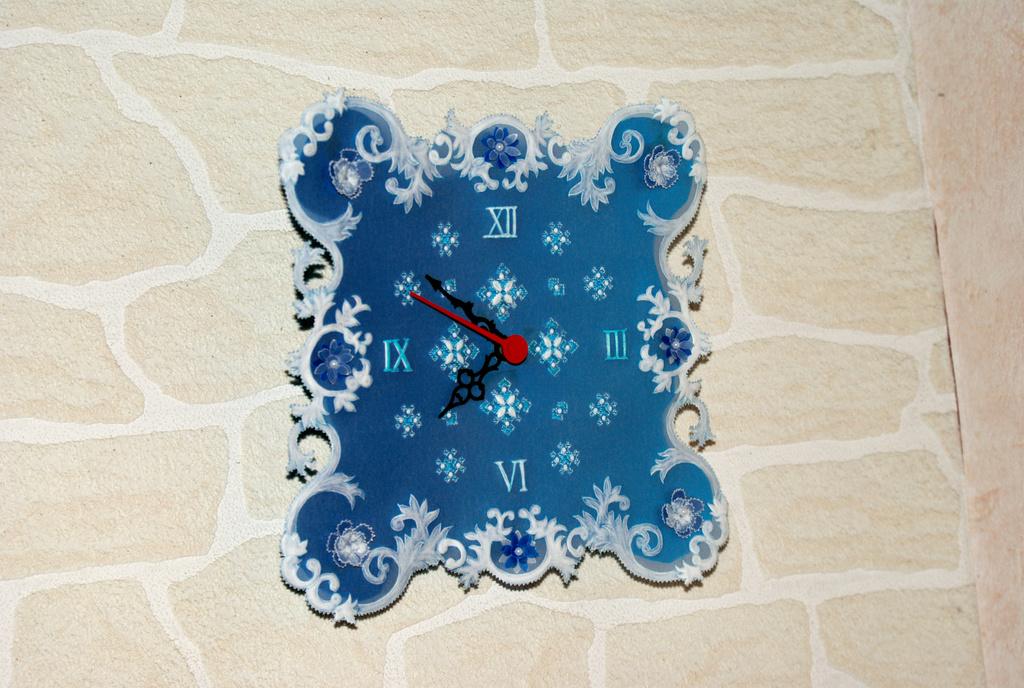What time does the clock read?
Make the answer very short. 7:52. What kind of numerals are the numbers?
Offer a terse response. Roman. 